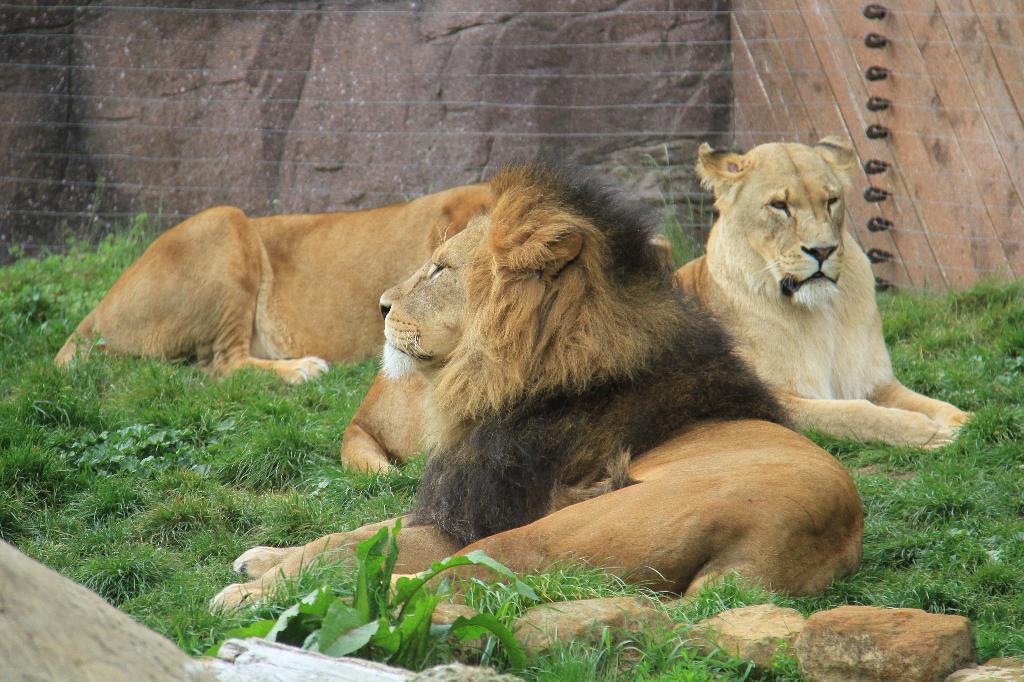How would you summarize this image in a sentence or two? In the center of the image we can see lions on the grass. In the background we can see wall. At the bottom of the image we can see stones and wood. 